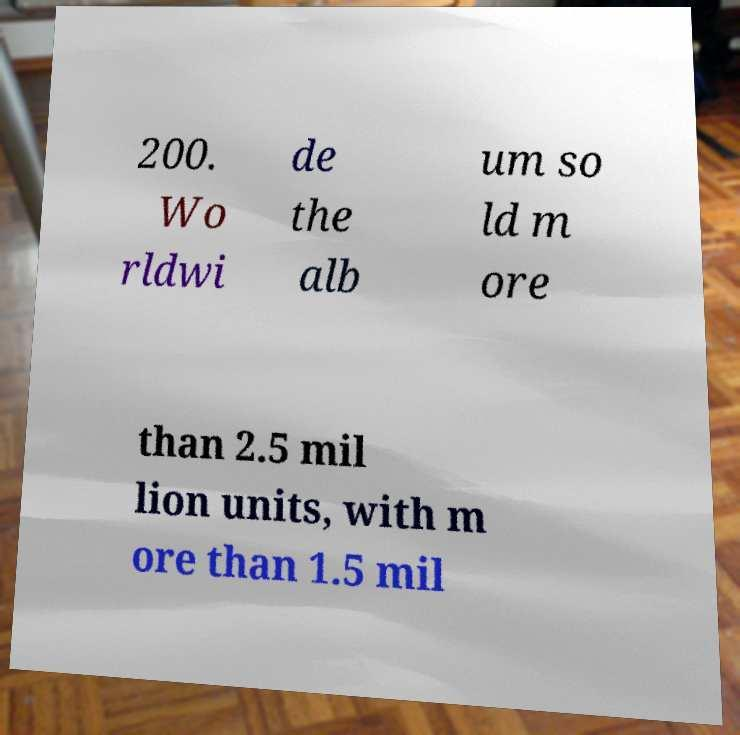Can you read and provide the text displayed in the image?This photo seems to have some interesting text. Can you extract and type it out for me? 200. Wo rldwi de the alb um so ld m ore than 2.5 mil lion units, with m ore than 1.5 mil 